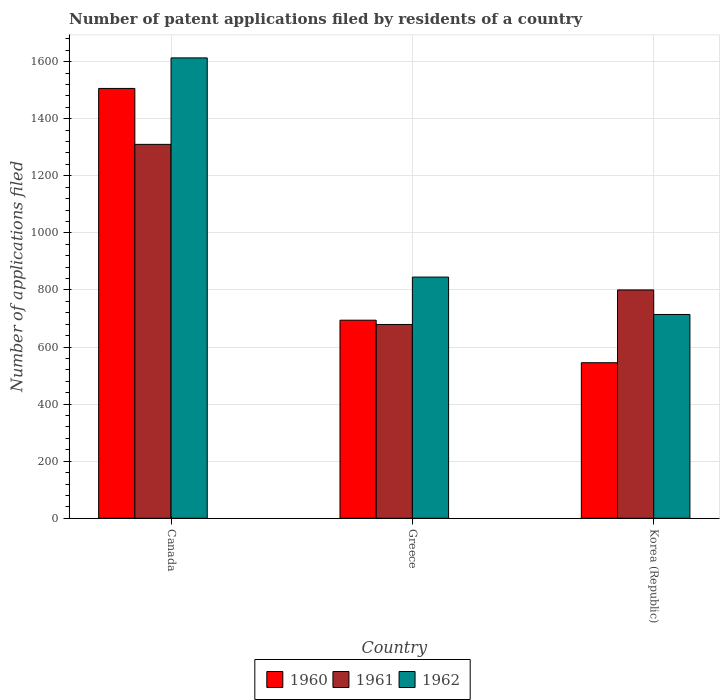How many different coloured bars are there?
Ensure brevity in your answer.  3. Are the number of bars per tick equal to the number of legend labels?
Your response must be concise. Yes. Are the number of bars on each tick of the X-axis equal?
Give a very brief answer. Yes. What is the number of applications filed in 1960 in Greece?
Your answer should be compact. 694. Across all countries, what is the maximum number of applications filed in 1962?
Make the answer very short. 1613. Across all countries, what is the minimum number of applications filed in 1962?
Offer a very short reply. 714. In which country was the number of applications filed in 1960 maximum?
Make the answer very short. Canada. What is the total number of applications filed in 1960 in the graph?
Offer a terse response. 2745. What is the difference between the number of applications filed in 1962 in Greece and that in Korea (Republic)?
Offer a very short reply. 131. What is the difference between the number of applications filed in 1961 in Greece and the number of applications filed in 1960 in Canada?
Your answer should be very brief. -827. What is the average number of applications filed in 1962 per country?
Your response must be concise. 1057.33. What is the difference between the number of applications filed of/in 1962 and number of applications filed of/in 1961 in Canada?
Offer a terse response. 303. In how many countries, is the number of applications filed in 1960 greater than 1560?
Your response must be concise. 0. What is the ratio of the number of applications filed in 1962 in Canada to that in Greece?
Your answer should be very brief. 1.91. What is the difference between the highest and the second highest number of applications filed in 1962?
Your response must be concise. -131. What is the difference between the highest and the lowest number of applications filed in 1960?
Offer a terse response. 961. What does the 2nd bar from the left in Greece represents?
Offer a very short reply. 1961. What does the 3rd bar from the right in Korea (Republic) represents?
Provide a short and direct response. 1960. Is it the case that in every country, the sum of the number of applications filed in 1962 and number of applications filed in 1960 is greater than the number of applications filed in 1961?
Provide a short and direct response. Yes. How many countries are there in the graph?
Give a very brief answer. 3. Does the graph contain any zero values?
Your answer should be very brief. No. Where does the legend appear in the graph?
Keep it short and to the point. Bottom center. How many legend labels are there?
Your answer should be compact. 3. What is the title of the graph?
Provide a short and direct response. Number of patent applications filed by residents of a country. Does "1963" appear as one of the legend labels in the graph?
Offer a terse response. No. What is the label or title of the Y-axis?
Provide a short and direct response. Number of applications filed. What is the Number of applications filed of 1960 in Canada?
Keep it short and to the point. 1506. What is the Number of applications filed in 1961 in Canada?
Make the answer very short. 1310. What is the Number of applications filed in 1962 in Canada?
Offer a terse response. 1613. What is the Number of applications filed in 1960 in Greece?
Offer a terse response. 694. What is the Number of applications filed of 1961 in Greece?
Offer a terse response. 679. What is the Number of applications filed of 1962 in Greece?
Give a very brief answer. 845. What is the Number of applications filed of 1960 in Korea (Republic)?
Provide a succinct answer. 545. What is the Number of applications filed in 1961 in Korea (Republic)?
Your answer should be very brief. 800. What is the Number of applications filed in 1962 in Korea (Republic)?
Your response must be concise. 714. Across all countries, what is the maximum Number of applications filed of 1960?
Offer a very short reply. 1506. Across all countries, what is the maximum Number of applications filed in 1961?
Give a very brief answer. 1310. Across all countries, what is the maximum Number of applications filed of 1962?
Make the answer very short. 1613. Across all countries, what is the minimum Number of applications filed of 1960?
Offer a very short reply. 545. Across all countries, what is the minimum Number of applications filed of 1961?
Give a very brief answer. 679. Across all countries, what is the minimum Number of applications filed in 1962?
Ensure brevity in your answer.  714. What is the total Number of applications filed in 1960 in the graph?
Provide a short and direct response. 2745. What is the total Number of applications filed of 1961 in the graph?
Provide a succinct answer. 2789. What is the total Number of applications filed of 1962 in the graph?
Offer a very short reply. 3172. What is the difference between the Number of applications filed of 1960 in Canada and that in Greece?
Offer a terse response. 812. What is the difference between the Number of applications filed of 1961 in Canada and that in Greece?
Your answer should be compact. 631. What is the difference between the Number of applications filed in 1962 in Canada and that in Greece?
Ensure brevity in your answer.  768. What is the difference between the Number of applications filed of 1960 in Canada and that in Korea (Republic)?
Keep it short and to the point. 961. What is the difference between the Number of applications filed of 1961 in Canada and that in Korea (Republic)?
Provide a succinct answer. 510. What is the difference between the Number of applications filed in 1962 in Canada and that in Korea (Republic)?
Ensure brevity in your answer.  899. What is the difference between the Number of applications filed in 1960 in Greece and that in Korea (Republic)?
Your response must be concise. 149. What is the difference between the Number of applications filed of 1961 in Greece and that in Korea (Republic)?
Provide a short and direct response. -121. What is the difference between the Number of applications filed in 1962 in Greece and that in Korea (Republic)?
Make the answer very short. 131. What is the difference between the Number of applications filed of 1960 in Canada and the Number of applications filed of 1961 in Greece?
Make the answer very short. 827. What is the difference between the Number of applications filed in 1960 in Canada and the Number of applications filed in 1962 in Greece?
Offer a very short reply. 661. What is the difference between the Number of applications filed of 1961 in Canada and the Number of applications filed of 1962 in Greece?
Your answer should be compact. 465. What is the difference between the Number of applications filed in 1960 in Canada and the Number of applications filed in 1961 in Korea (Republic)?
Your answer should be compact. 706. What is the difference between the Number of applications filed in 1960 in Canada and the Number of applications filed in 1962 in Korea (Republic)?
Your answer should be very brief. 792. What is the difference between the Number of applications filed of 1961 in Canada and the Number of applications filed of 1962 in Korea (Republic)?
Your answer should be very brief. 596. What is the difference between the Number of applications filed of 1960 in Greece and the Number of applications filed of 1961 in Korea (Republic)?
Keep it short and to the point. -106. What is the difference between the Number of applications filed in 1961 in Greece and the Number of applications filed in 1962 in Korea (Republic)?
Give a very brief answer. -35. What is the average Number of applications filed of 1960 per country?
Your answer should be compact. 915. What is the average Number of applications filed in 1961 per country?
Provide a succinct answer. 929.67. What is the average Number of applications filed in 1962 per country?
Your answer should be compact. 1057.33. What is the difference between the Number of applications filed of 1960 and Number of applications filed of 1961 in Canada?
Make the answer very short. 196. What is the difference between the Number of applications filed in 1960 and Number of applications filed in 1962 in Canada?
Offer a terse response. -107. What is the difference between the Number of applications filed in 1961 and Number of applications filed in 1962 in Canada?
Offer a terse response. -303. What is the difference between the Number of applications filed in 1960 and Number of applications filed in 1961 in Greece?
Ensure brevity in your answer.  15. What is the difference between the Number of applications filed in 1960 and Number of applications filed in 1962 in Greece?
Offer a terse response. -151. What is the difference between the Number of applications filed in 1961 and Number of applications filed in 1962 in Greece?
Make the answer very short. -166. What is the difference between the Number of applications filed of 1960 and Number of applications filed of 1961 in Korea (Republic)?
Offer a terse response. -255. What is the difference between the Number of applications filed of 1960 and Number of applications filed of 1962 in Korea (Republic)?
Keep it short and to the point. -169. What is the difference between the Number of applications filed of 1961 and Number of applications filed of 1962 in Korea (Republic)?
Your answer should be compact. 86. What is the ratio of the Number of applications filed of 1960 in Canada to that in Greece?
Provide a succinct answer. 2.17. What is the ratio of the Number of applications filed of 1961 in Canada to that in Greece?
Your response must be concise. 1.93. What is the ratio of the Number of applications filed of 1962 in Canada to that in Greece?
Ensure brevity in your answer.  1.91. What is the ratio of the Number of applications filed in 1960 in Canada to that in Korea (Republic)?
Offer a very short reply. 2.76. What is the ratio of the Number of applications filed in 1961 in Canada to that in Korea (Republic)?
Offer a very short reply. 1.64. What is the ratio of the Number of applications filed in 1962 in Canada to that in Korea (Republic)?
Offer a terse response. 2.26. What is the ratio of the Number of applications filed of 1960 in Greece to that in Korea (Republic)?
Give a very brief answer. 1.27. What is the ratio of the Number of applications filed of 1961 in Greece to that in Korea (Republic)?
Offer a terse response. 0.85. What is the ratio of the Number of applications filed of 1962 in Greece to that in Korea (Republic)?
Ensure brevity in your answer.  1.18. What is the difference between the highest and the second highest Number of applications filed of 1960?
Provide a short and direct response. 812. What is the difference between the highest and the second highest Number of applications filed in 1961?
Give a very brief answer. 510. What is the difference between the highest and the second highest Number of applications filed of 1962?
Your answer should be compact. 768. What is the difference between the highest and the lowest Number of applications filed of 1960?
Keep it short and to the point. 961. What is the difference between the highest and the lowest Number of applications filed of 1961?
Give a very brief answer. 631. What is the difference between the highest and the lowest Number of applications filed in 1962?
Keep it short and to the point. 899. 